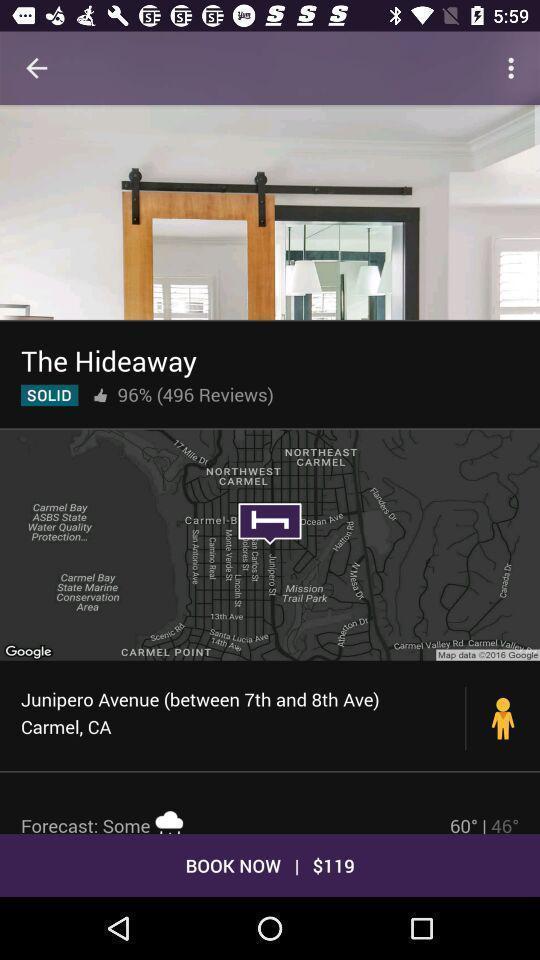Tell me what you see in this picture. Screen showing book now option. 